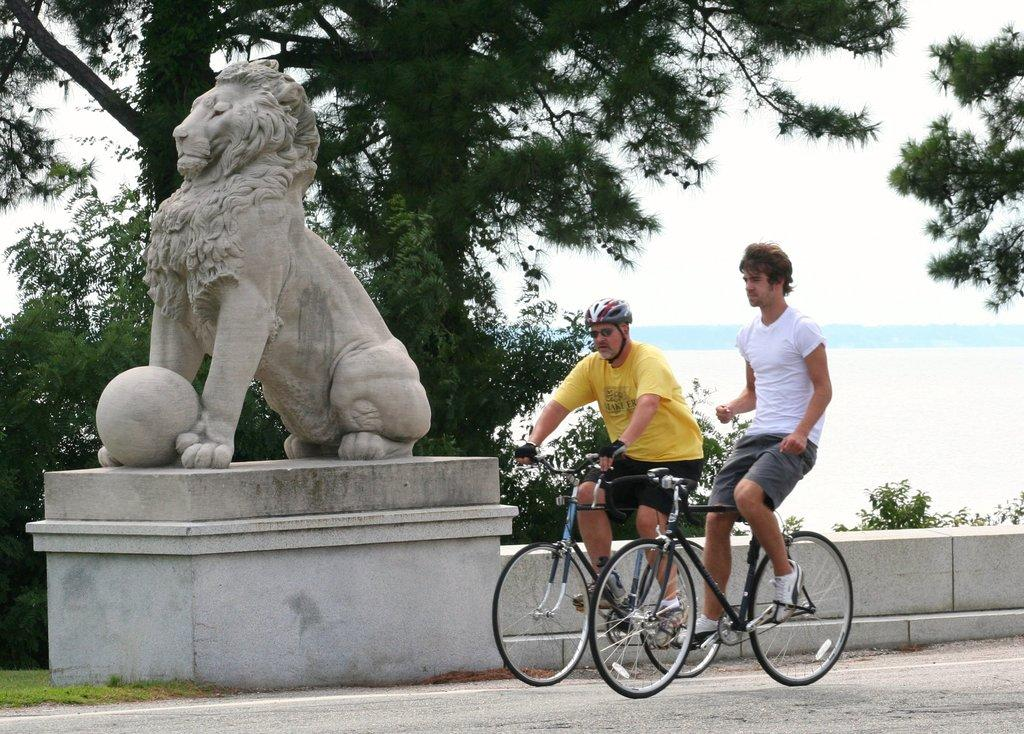What is the main subject of the image? There is a Lions sculpture in the image. What is located beside the Lions sculpture? There is a ball beside the Lions sculpture. What are the two men in the image doing? The two men are riding bicycles. How many pigs are visible in the image? There are no pigs present in the image. What type of knot is being used to secure the ball to the Lions sculpture? There is no knot present in the image, as the ball is simply placed beside the sculpture. 